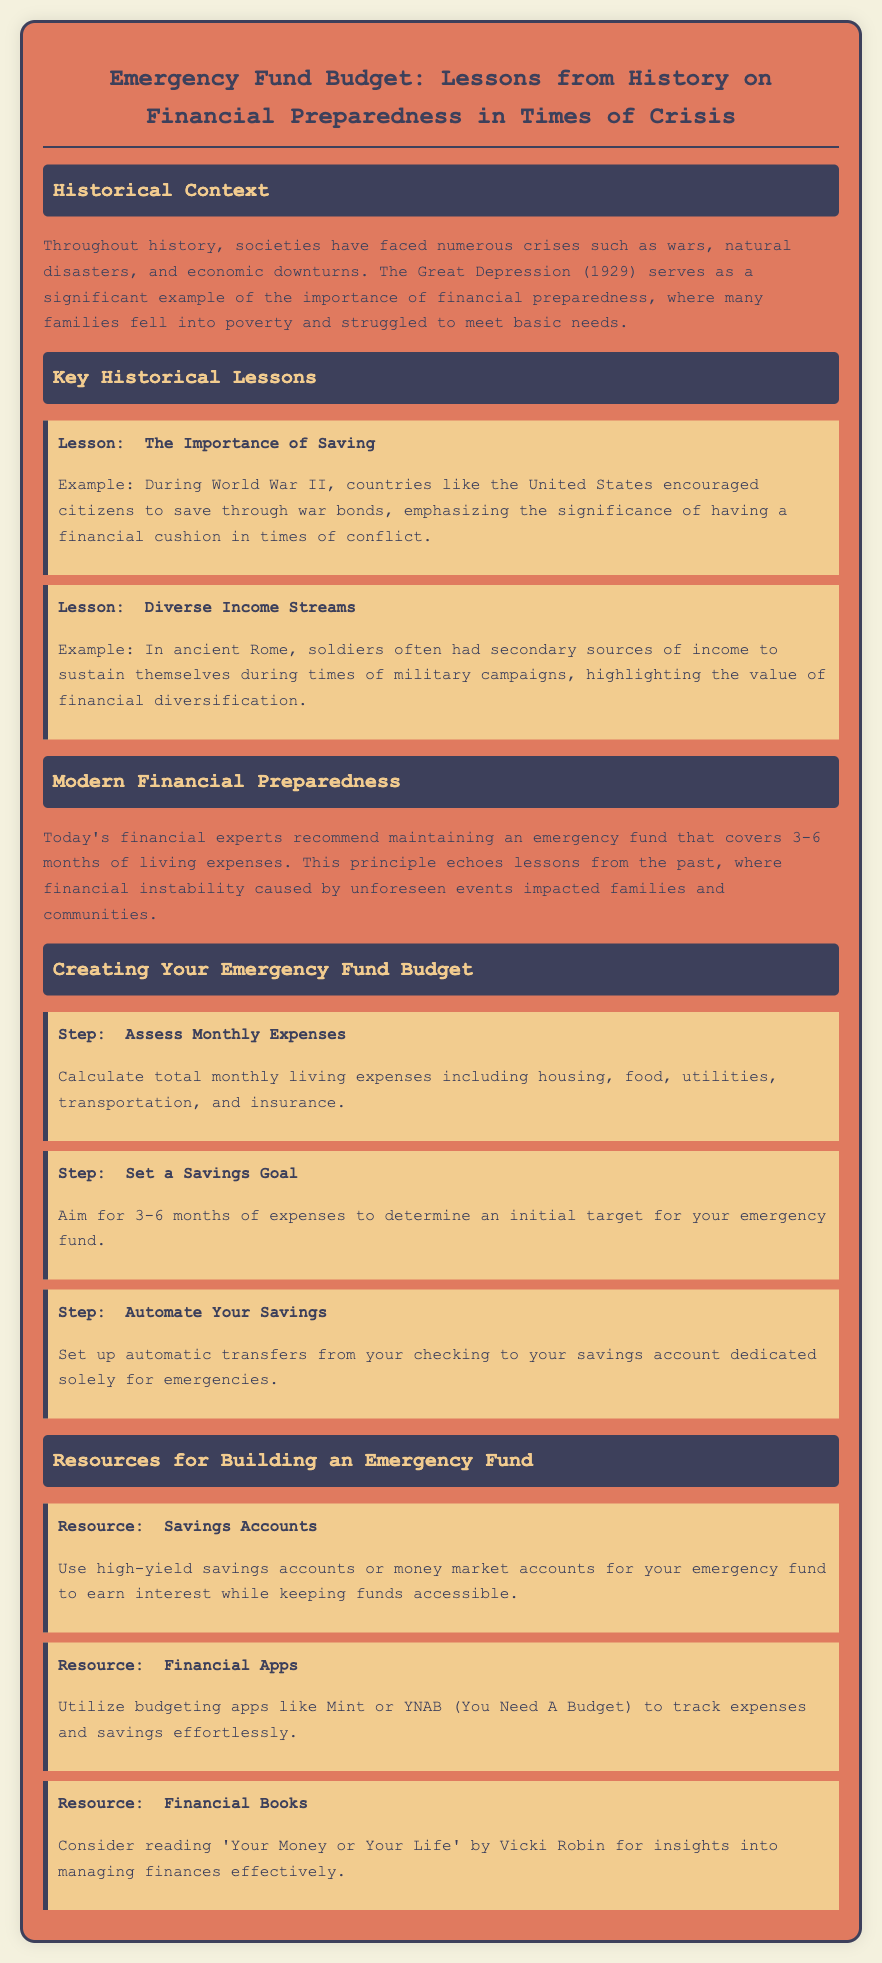What is the historical example of financial preparedness mentioned? The document mentions the Great Depression (1929) as a significant example of financial preparedness.
Answer: Great Depression (1929) What is the suggested duration for maintaining an emergency fund? The document recommends maintaining an emergency fund that covers 3-6 months of living expenses.
Answer: 3-6 months Which country encouraged saving through war bonds during World War II? The document states that the United States encouraged citizens to save through war bonds during World War II.
Answer: United States What is the first step in creating an emergency fund budget? The first step listed in the document is to assess monthly expenses.
Answer: Assess Monthly Expenses What financial resource is recommended for tracking expenses effortlessly? The document mentions utilizing budgeting apps like Mint or YNAB for tracking expenses and savings.
Answer: Budgeting apps What underlying lesson is emphasized by the example from ancient Rome? The lesson highlighted is about the value of financial diversification through having secondary income sources.
Answer: Financial diversification How many months of expenses should one aim for in their emergency fund goal? The document suggests one should aim for 3-6 months of expenses for their emergency fund goal.
Answer: 3-6 months What type of accounts should be used for an emergency fund? The document recommends using high-yield savings accounts or money market accounts for the emergency fund.
Answer: High-yield savings accounts 